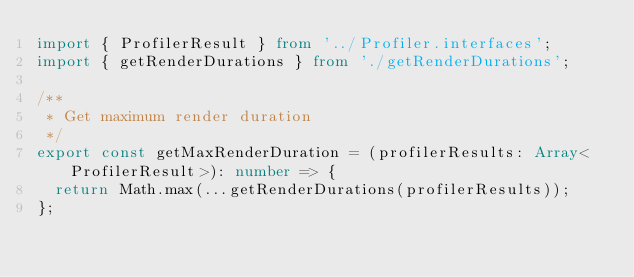Convert code to text. <code><loc_0><loc_0><loc_500><loc_500><_TypeScript_>import { ProfilerResult } from '../Profiler.interfaces';
import { getRenderDurations } from './getRenderDurations';

/**
 * Get maximum render duration
 */
export const getMaxRenderDuration = (profilerResults: Array<ProfilerResult>): number => {
  return Math.max(...getRenderDurations(profilerResults));
};
</code> 